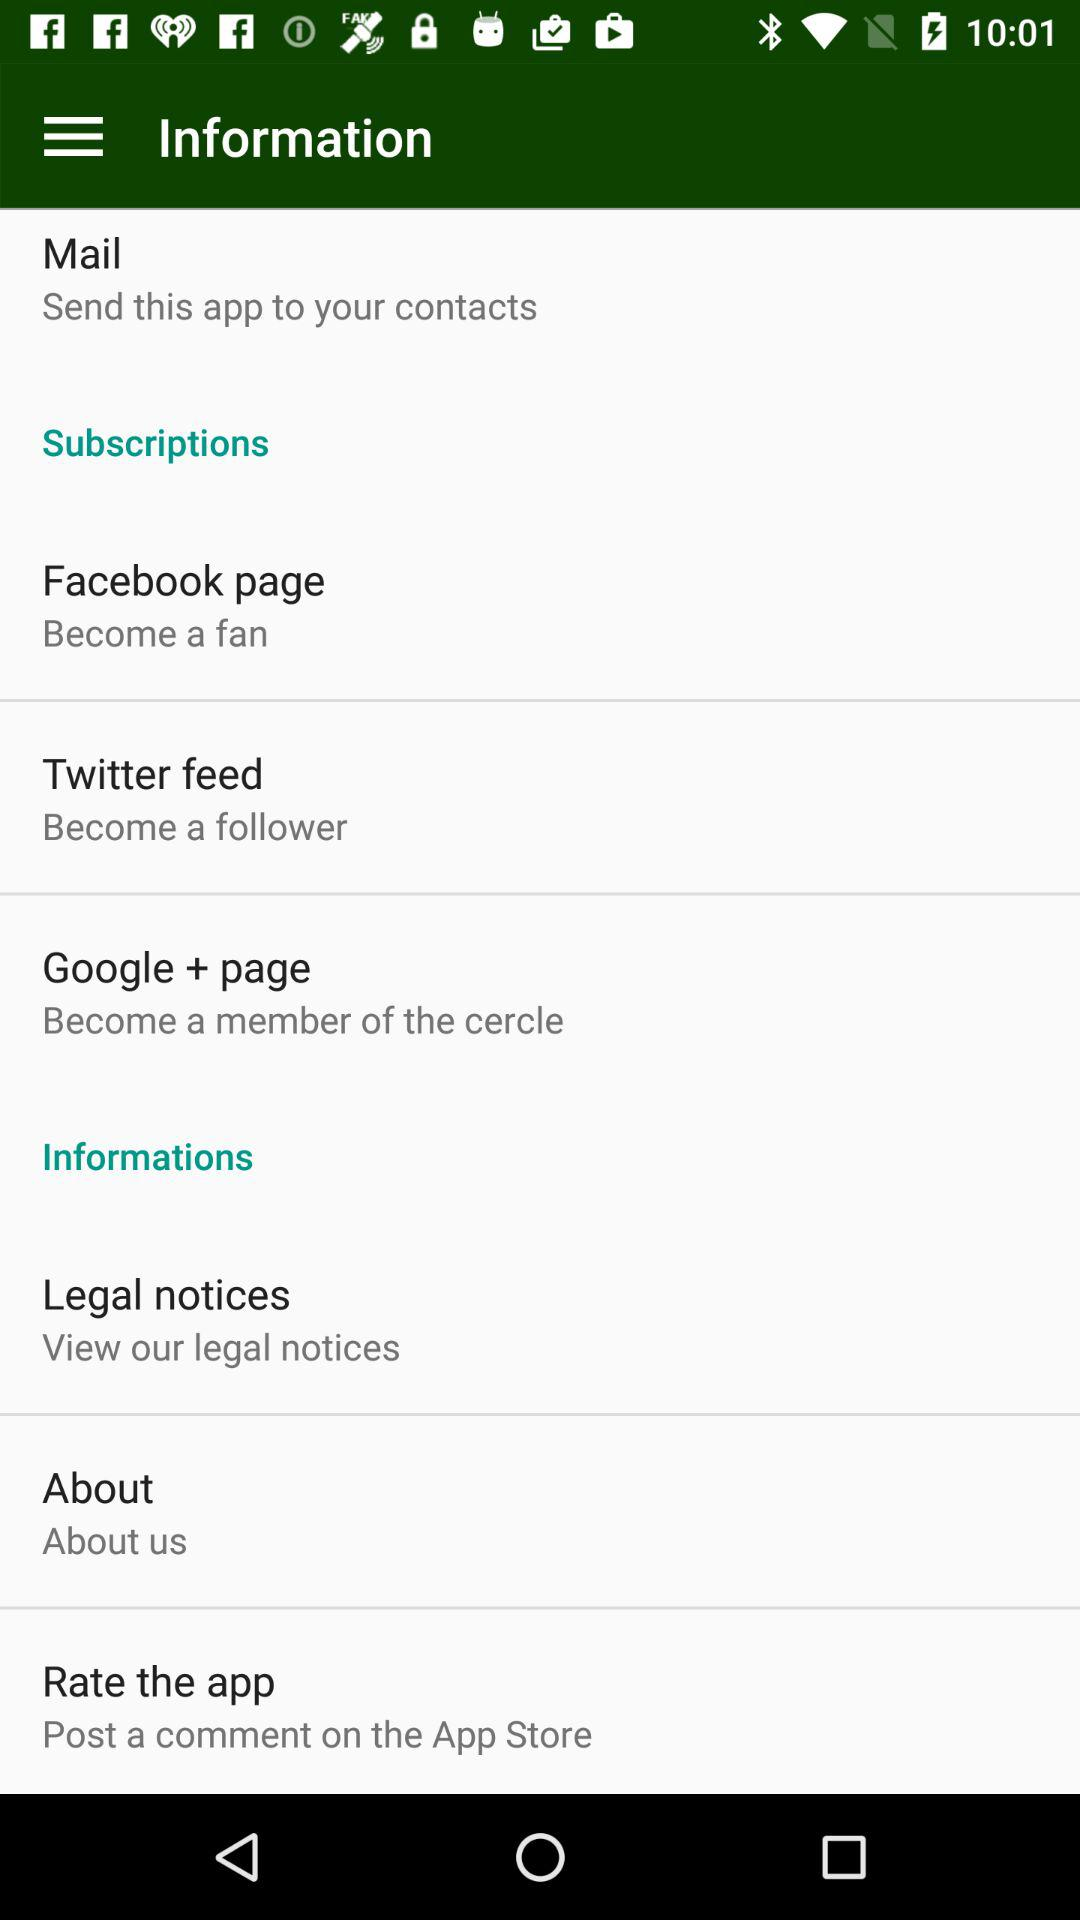Where can I send the application? You can send the application to your contacts. 